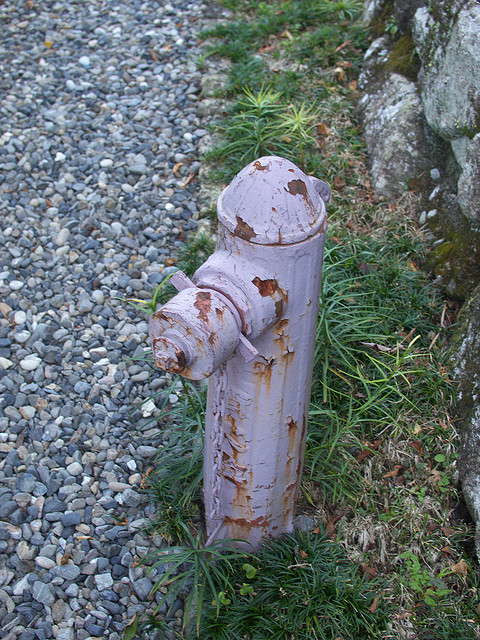Based on the wear and tear, can we infer anything about the fireplug's age or usage? The wear and tear on the fireplug, particularly the chipping paint, indicates that it has likely been in place for a significant amount of time and has endured various weather conditions. While its exact age is uncertain, the absence of recent maintenance or repainting suggests it may not have been frequently used or well-maintained. 